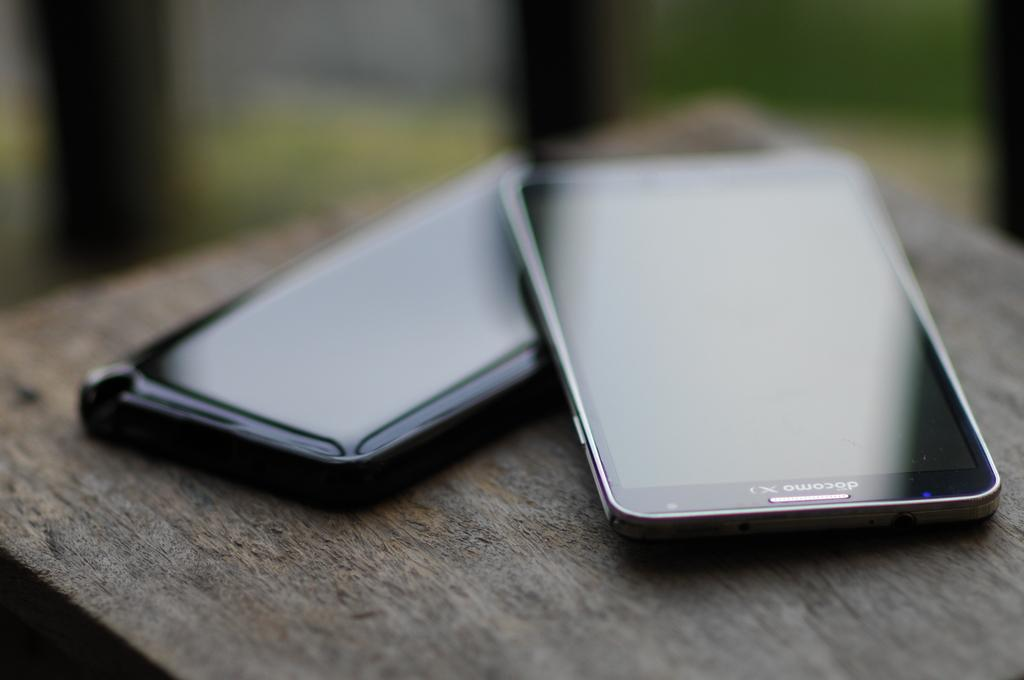<image>
Offer a succinct explanation of the picture presented. A close up of two mobile phones, one resting on the other with screens that cannot be seen because of light glare. 